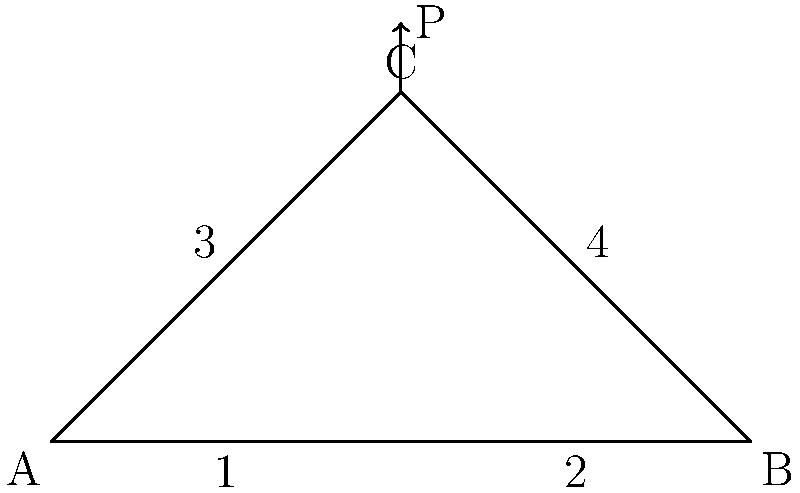In the truss bridge shown above, a point load P is applied at node C. Assuming the truss is statically determinate and all joints are pinned, which member(s) will experience the highest axial stress? Justify your answer based on the stress distribution principles in truss structures. To determine which member(s) will experience the highest axial stress, we need to consider the following principles:

1. Force distribution: The point load P at node C will be distributed through the truss members to the supports at A and B.

2. Truss geometry: The truss is symmetrical, which suggests that the force distribution will be symmetrical as well.

3. Member orientation: Members 3 and 4 are inclined, while members 1 and 2 are horizontal.

4. Stress calculation: Stress is calculated as force divided by cross-sectional area (σ = F/A).

Step-by-step analysis:

1. The vertical component of P will be equally distributed to the supports at A and B due to symmetry.

2. Members 3 and 4 will carry the vertical load directly to the supports. They will experience both tension and compression forces.

3. Members 1 and 2 will mainly experience horizontal forces to maintain equilibrium.

4. The inclined members (3 and 4) will carry a larger portion of the load compared to the horizontal members (1 and 2).

5. Assuming all members have the same cross-sectional area, the members carrying larger forces will experience higher stresses.

6. Due to their inclination and direct connection to the load point, members 3 and 4 are likely to experience the highest axial stresses.

It's important to note that without specific numerical values for the load and member properties, we cannot determine the exact stress values. However, based on the principles of truss behavior, we can conclude that members 3 and 4 are most likely to experience the highest axial stresses.
Answer: Members 3 and 4 